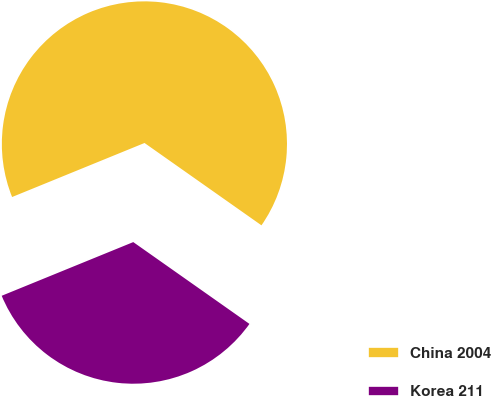<chart> <loc_0><loc_0><loc_500><loc_500><pie_chart><fcel>China 2004<fcel>Korea 211<nl><fcel>65.93%<fcel>34.07%<nl></chart> 